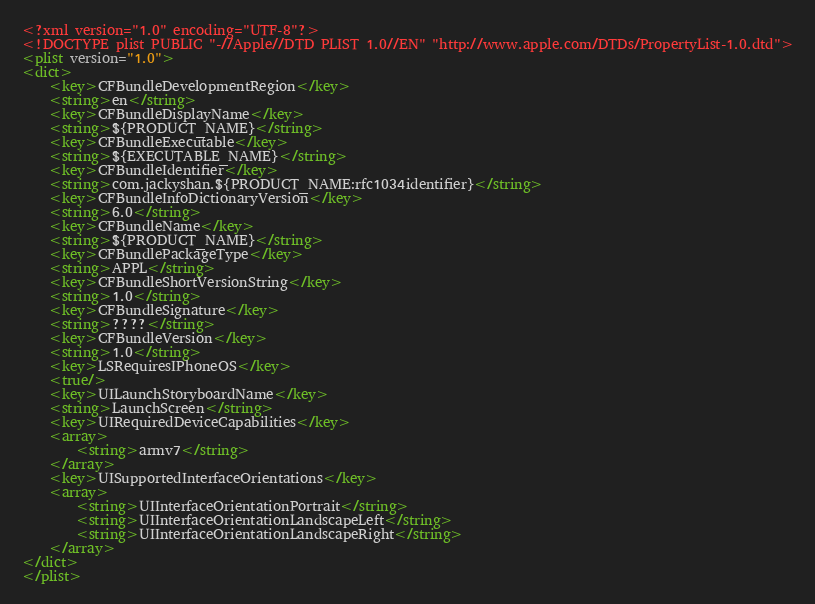<code> <loc_0><loc_0><loc_500><loc_500><_XML_><?xml version="1.0" encoding="UTF-8"?>
<!DOCTYPE plist PUBLIC "-//Apple//DTD PLIST 1.0//EN" "http://www.apple.com/DTDs/PropertyList-1.0.dtd">
<plist version="1.0">
<dict>
	<key>CFBundleDevelopmentRegion</key>
	<string>en</string>
	<key>CFBundleDisplayName</key>
	<string>${PRODUCT_NAME}</string>
	<key>CFBundleExecutable</key>
	<string>${EXECUTABLE_NAME}</string>
	<key>CFBundleIdentifier</key>
	<string>com.jackyshan.${PRODUCT_NAME:rfc1034identifier}</string>
	<key>CFBundleInfoDictionaryVersion</key>
	<string>6.0</string>
	<key>CFBundleName</key>
	<string>${PRODUCT_NAME}</string>
	<key>CFBundlePackageType</key>
	<string>APPL</string>
	<key>CFBundleShortVersionString</key>
	<string>1.0</string>
	<key>CFBundleSignature</key>
	<string>????</string>
	<key>CFBundleVersion</key>
	<string>1.0</string>
	<key>LSRequiresIPhoneOS</key>
	<true/>
	<key>UILaunchStoryboardName</key>
	<string>LaunchScreen</string>
	<key>UIRequiredDeviceCapabilities</key>
	<array>
		<string>armv7</string>
	</array>
	<key>UISupportedInterfaceOrientations</key>
	<array>
		<string>UIInterfaceOrientationPortrait</string>
		<string>UIInterfaceOrientationLandscapeLeft</string>
		<string>UIInterfaceOrientationLandscapeRight</string>
	</array>
</dict>
</plist>
</code> 